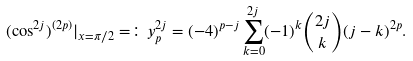Convert formula to latex. <formula><loc_0><loc_0><loc_500><loc_500>( \cos ^ { 2 j } ) ^ { ( 2 p ) } | _ { x = \pi / 2 } = \colon y ^ { 2 j } _ { p } = ( - 4 ) ^ { p - j } \sum _ { k = 0 } ^ { 2 j } ( - 1 ) ^ { k } \binom { 2 j } { k } ( j - k ) ^ { 2 p } .</formula> 